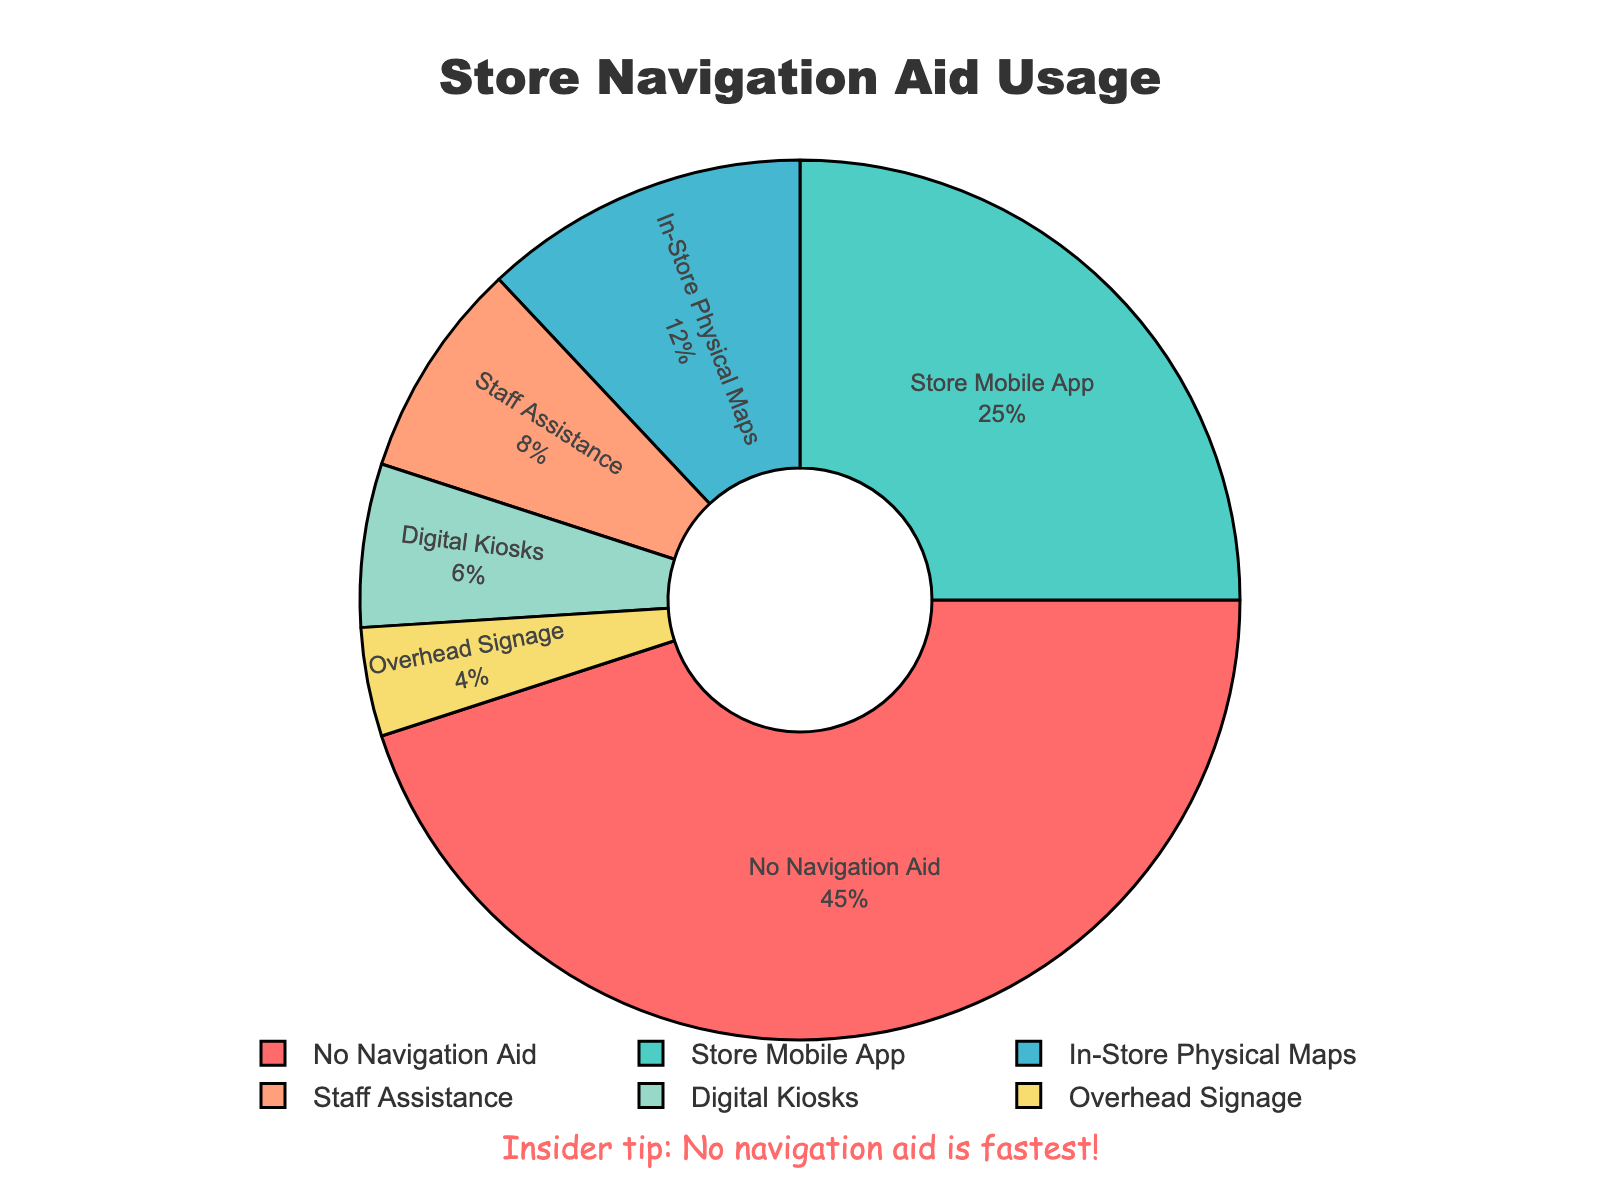Which navigation method is used by the highest proportion of customers? In the pie chart, the section labeled "No Navigation Aid" appears the largest, indicative of the highest proportion. The corresponding percentage is 45%.
Answer: No Navigation Aid If you sum the percentages of customers using "Store Mobile App" and "In-Store Physical Maps," what is the result? From the figure, the percentage for "Store Mobile App" is 25%, and for "In-Store Physical Maps" is 12%. Summing these gives 25 + 12 = 37%.
Answer: 37% Which navigation method is used by a smaller proportion of customers, "Staff Assistance" or "Digital Kiosks"? The pie chart shows "Staff Assistance" with 8% and "Digital Kiosks" with 6%. Since 6% is smaller than 8%, fewer customers use "Digital Kiosks."
Answer: Digital Kiosks What is the combined percentage of customers using "Overhead Signage" and "Digital Kiosks"? The figure shows "Overhead Signage" at 4% and "Digital Kiosks" at 6%. Adding these gives 4 + 6 = 10%.
Answer: 10% How much larger is the percentage of customers using "In-Store Physical Maps" compared to those using "Overhead Signage"? According to the chart, "In-Store Physical Maps" is 12% and "Overhead Signage" is 4%. The difference is 12 - 4 = 8%.
Answer: 8% Which section in the pie chart is colored red, and what percentage does it represent? The red section of the pie chart represents "No Navigation Aid," which is the largest section with 45%.
Answer: 45% Arrange the navigation aids in descending order of their usage percentages. Referring to the chart, the percentages from largest to smallest are: "No Navigation Aid" (45%), "Store Mobile App" (25%), "In-Store Physical Maps" (12%), "Staff Assistance" (8%), "Digital Kiosks" (6%), and "Overhead Signage" (4%).
Answer: No Navigation Aid, Store Mobile App, In-Store Physical Maps, Staff Assistance, Digital Kiosks, Overhead Signage What percentage of customers do not use any form of navigation aid? Looking at the pie chart, the section for "No Navigation Aid" shows a percentage of 45%.
Answer: 45% Which two navigation methods together account for exactly 20% of customer usage? According to the chart, "Staff Assistance" is 8% and "Digital Kiosks" is 6%, adding to 14%. "Digital Kiosks" is 6% and "Overhead Signage" is 4%, adding to 10%. "Store Mobile App" is 25% alone. No two navigation methods sum up exactly to 20%.
Answer: None What percentage difference is there between the most and least used navigation methods? The most used method is "No Navigation Aid" at 45%, and the least used is "Overhead Signage" at 4%. The difference is 45 - 4 = 41%.
Answer: 41% 